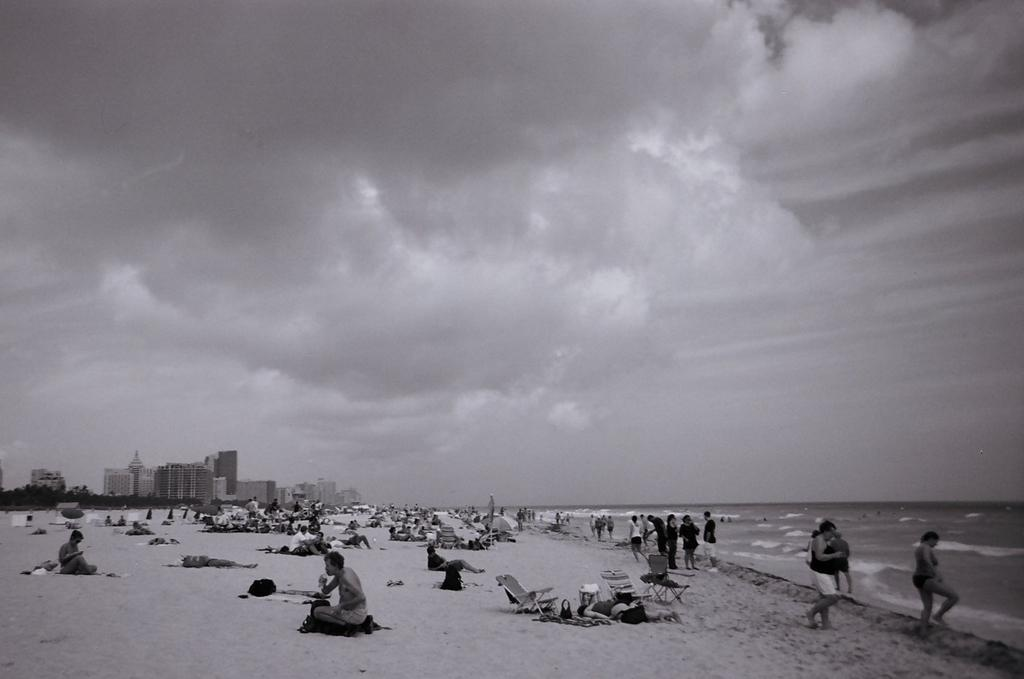How many people can be seen in the image? There are many people in the image. What are the people wearing? The people are wearing clothes. What type of seating is available in the image? There are beach chairs in the image. What is the texture of the ground in the image? The ground is sandy. What can be seen in the water in the image? The water is visible in the image, but it is not clear what is happening in it. What structures can be seen in the background of the image? There are buildings in the background of the image. What type of vegetation is present in the background of the image? Trees are present in the background of the image. What is the weather like in the image? The sky is cloudy in the image. Can you hear the farmer whistling in the image? There is no farmer or whistling present in the image. What type of precipitation is falling from the sky in the image? The sky is cloudy, but there is no indication of precipitation, such as sleet, in the image. 